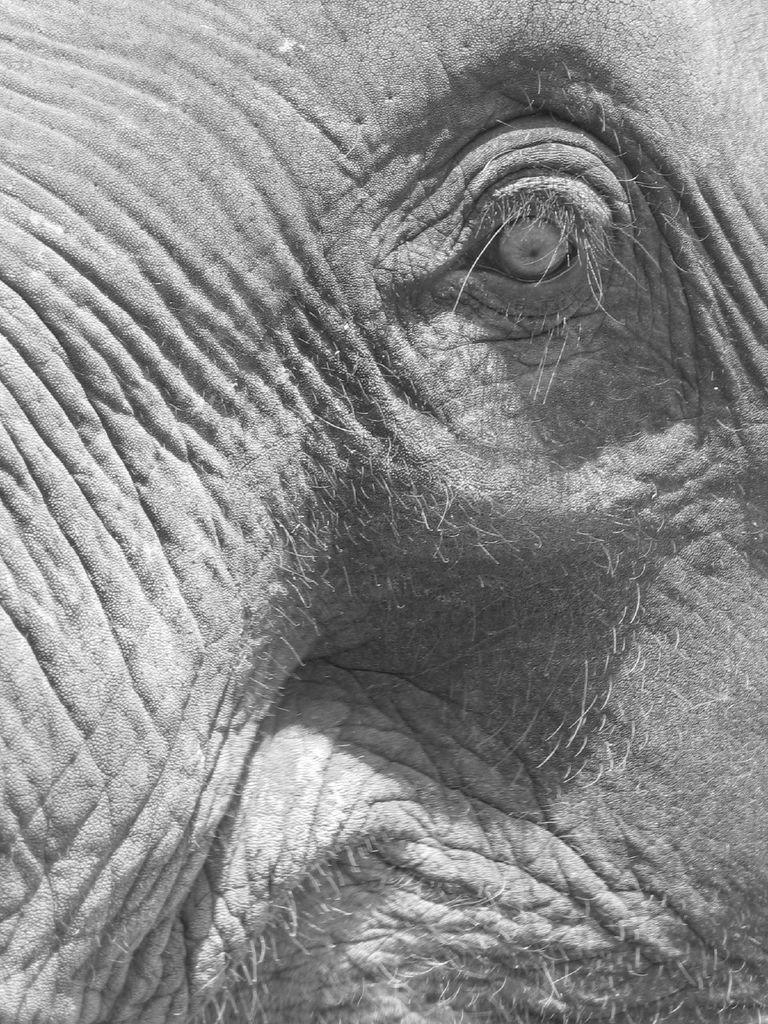Please provide a concise description of this image. In this black and white picture there is an eye of an elephant. There are hairs on the body of the elephant. 